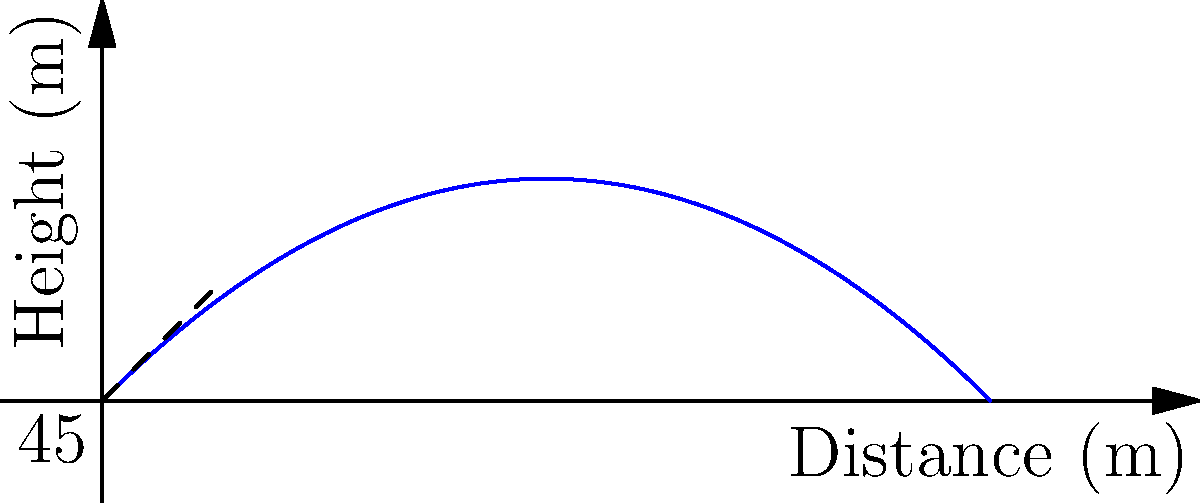As a PR consultant for a famous baseball player, you're analyzing a spectacular throw. The player throws a baseball with an initial velocity of 40 m/s at a 45° angle from the horizontal. Assuming air resistance is negligible, what is the maximum height reached by the baseball during its flight? To find the maximum height, we'll follow these steps:

1) The vertical component of velocity is given by:
   $v_y = v_0 \sin(\theta) = 40 \cdot \sin(45°) = 40 \cdot \frac{\sqrt{2}}{2} \approx 28.28$ m/s

2) The time to reach maximum height is when the vertical velocity becomes zero:
   $t_{max} = \frac{v_y}{g} = \frac{28.28}{9.8} \approx 2.89$ seconds

3) The maximum height is given by the equation:
   $h_{max} = v_y t - \frac{1}{2}gt^2$

4) Substituting the values:
   $h_{max} = 28.28 \cdot 2.89 - \frac{1}{2} \cdot 9.8 \cdot 2.89^2$

5) Calculating:
   $h_{max} = 81.73 - 40.86 = 40.87$ meters

Therefore, the maximum height reached by the baseball is approximately 40.87 meters.
Answer: 40.87 meters 